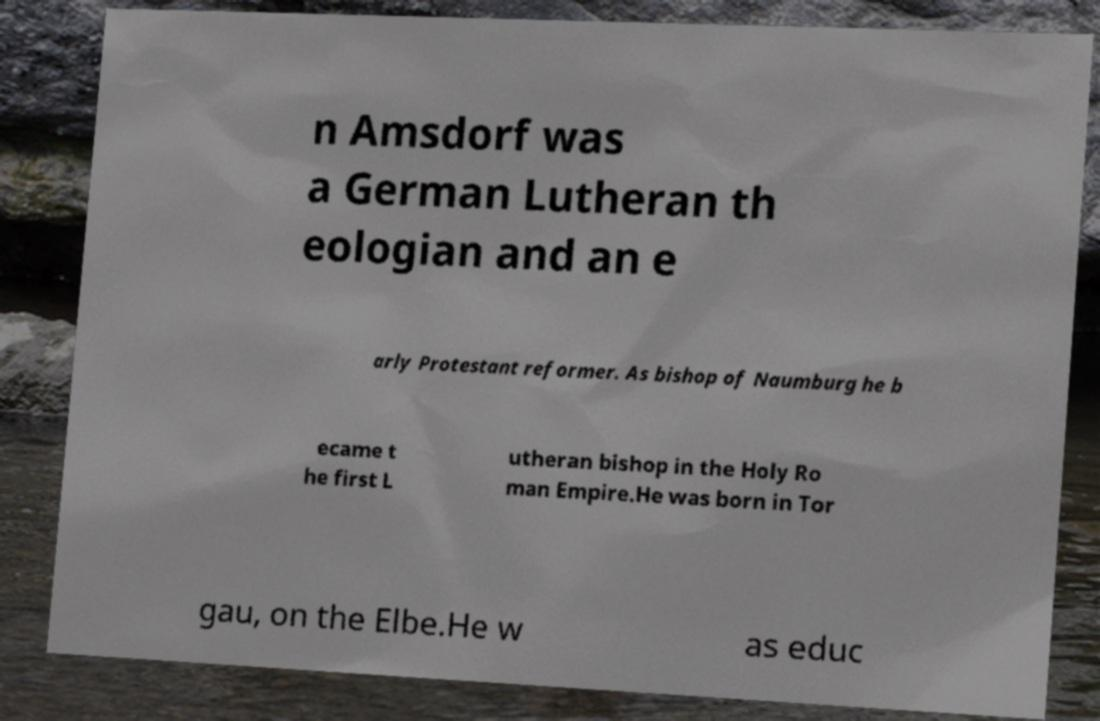Please read and relay the text visible in this image. What does it say? n Amsdorf was a German Lutheran th eologian and an e arly Protestant reformer. As bishop of Naumburg he b ecame t he first L utheran bishop in the Holy Ro man Empire.He was born in Tor gau, on the Elbe.He w as educ 